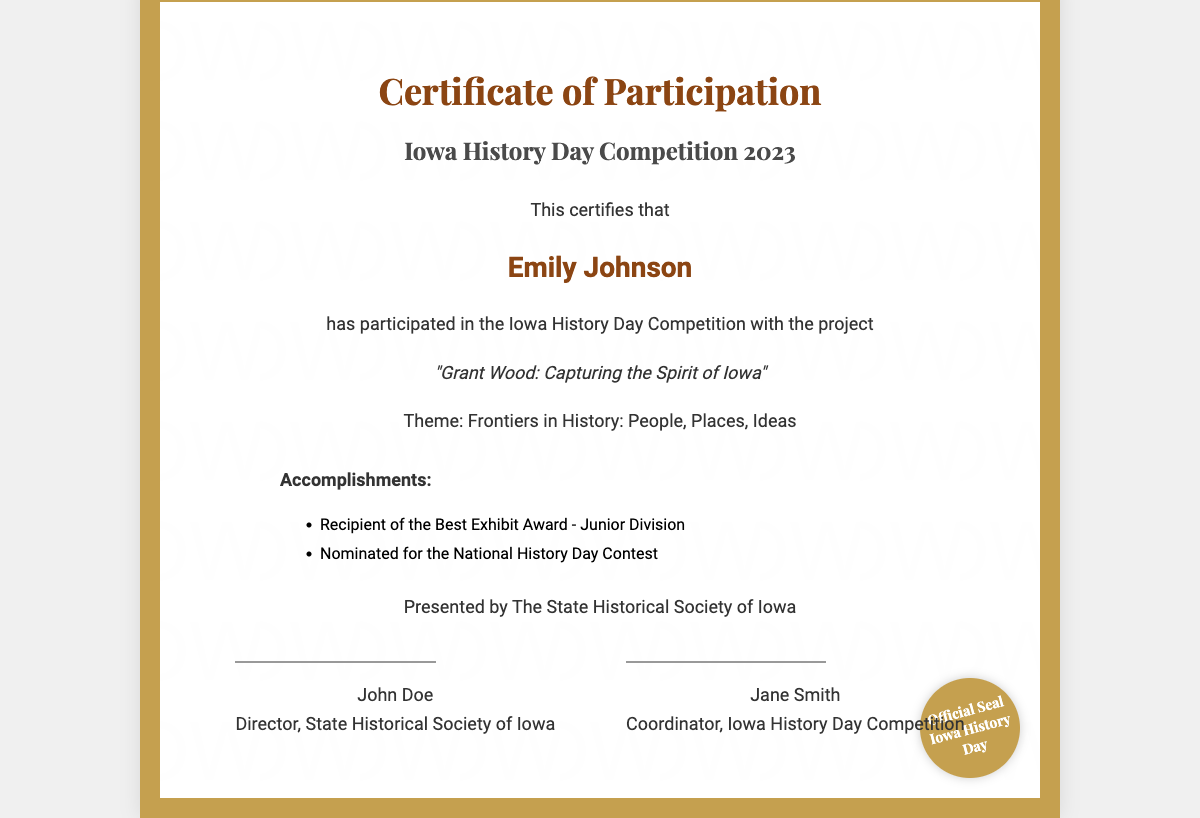what is the participant's name? The participant's name is prominently displayed in the document, which is "Emily Johnson."
Answer: Emily Johnson what is the theme of the competition? The theme for the Iowa History Day Competition 2023 is specified in the document, which is "Frontiers in History: People, Places, Ideas."
Answer: Frontiers in History: People, Places, Ideas what project title did the participant present? The project title is mentioned in the document as the title of Emily's project, which is "Grant Wood: Capturing the Spirit of Iowa."
Answer: Grant Wood: Capturing the Spirit of Iowa how many awards did the participant receive? The participant received a specific recognition in the form of awards detailed in the accomplishments section, which states two awards.
Answer: 2 who issued the certificate? The issuer is referred to in the document where it states "Presented by The State Historical Society of Iowa."
Answer: The State Historical Society of Iowa what is the award received in the Junior Division? One of the accomplishments lists the specific award received in the Junior Division, which is the "Best Exhibit Award."
Answer: Best Exhibit Award which contest was Emily Johnson nominated for? The document mentions a specific contest that Emily was nominated for, which is the "National History Day Contest."
Answer: National History Day Contest how many signatures are on the certificate? The document shows there are two signatures included, indicating the individuals who authorized the certificate.
Answer: 2 what type of document is this? The title at the top of the document clarifies what it is, which is a "Certificate of Participation."
Answer: Certificate of Participation 